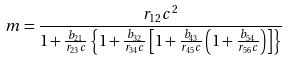<formula> <loc_0><loc_0><loc_500><loc_500>m = \frac { r _ { 1 2 } c ^ { 2 } } { 1 + \frac { b _ { 2 1 } } { r _ { 2 3 } c } \left \{ 1 + \frac { b _ { 3 2 } } { r _ { 3 4 } c } \left [ 1 + \frac { b _ { 4 3 } } { r _ { 4 5 } c } \left ( 1 + \frac { b _ { 5 4 } } { r _ { 5 6 } c } \right ) \right ] \right \} }</formula> 